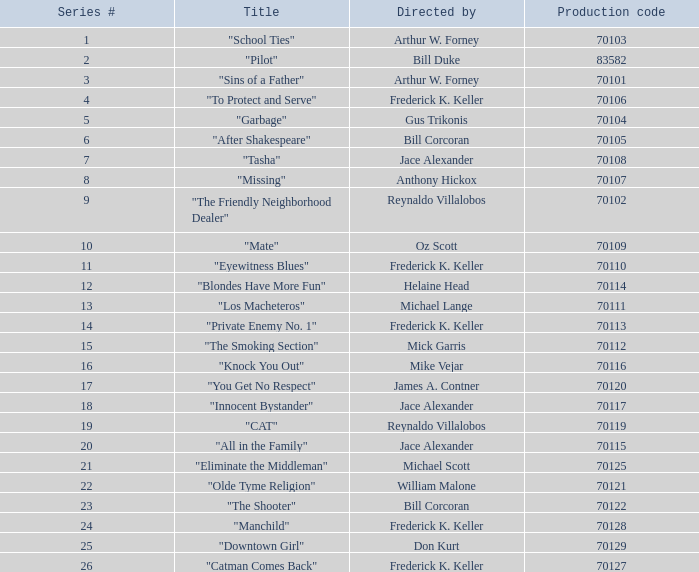What was the lowest production code value in series #10? 70109.0. 